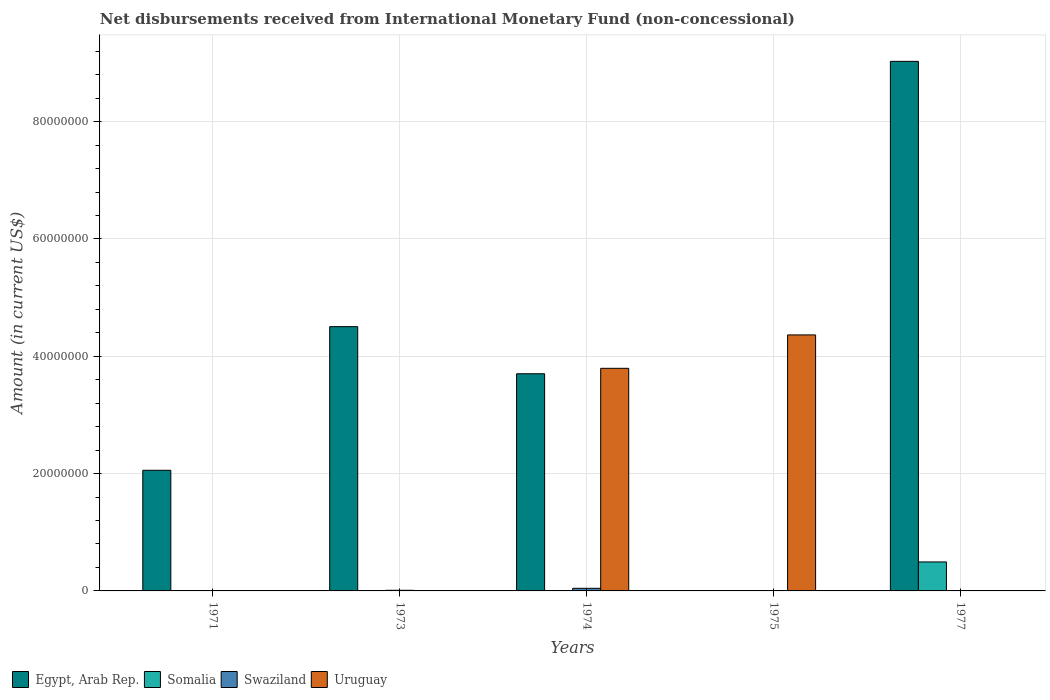How many different coloured bars are there?
Ensure brevity in your answer.  4. Are the number of bars per tick equal to the number of legend labels?
Your response must be concise. No. What is the label of the 4th group of bars from the left?
Provide a succinct answer. 1975. In how many cases, is the number of bars for a given year not equal to the number of legend labels?
Offer a very short reply. 5. What is the amount of disbursements received from International Monetary Fund in Uruguay in 1974?
Keep it short and to the point. 3.79e+07. Across all years, what is the maximum amount of disbursements received from International Monetary Fund in Egypt, Arab Rep.?
Give a very brief answer. 9.03e+07. What is the total amount of disbursements received from International Monetary Fund in Uruguay in the graph?
Provide a succinct answer. 8.16e+07. What is the difference between the amount of disbursements received from International Monetary Fund in Swaziland in 1973 and that in 1974?
Provide a succinct answer. -3.37e+05. What is the average amount of disbursements received from International Monetary Fund in Swaziland per year?
Your response must be concise. 1.11e+05. In the year 1973, what is the difference between the amount of disbursements received from International Monetary Fund in Swaziland and amount of disbursements received from International Monetary Fund in Egypt, Arab Rep.?
Your answer should be very brief. -4.49e+07. In how many years, is the amount of disbursements received from International Monetary Fund in Egypt, Arab Rep. greater than 24000000 US$?
Make the answer very short. 3. What is the difference between the highest and the second highest amount of disbursements received from International Monetary Fund in Egypt, Arab Rep.?
Give a very brief answer. 4.52e+07. What is the difference between the highest and the lowest amount of disbursements received from International Monetary Fund in Swaziland?
Your answer should be compact. 4.45e+05. Is it the case that in every year, the sum of the amount of disbursements received from International Monetary Fund in Swaziland and amount of disbursements received from International Monetary Fund in Somalia is greater than the sum of amount of disbursements received from International Monetary Fund in Uruguay and amount of disbursements received from International Monetary Fund in Egypt, Arab Rep.?
Your answer should be compact. No. Is it the case that in every year, the sum of the amount of disbursements received from International Monetary Fund in Somalia and amount of disbursements received from International Monetary Fund in Swaziland is greater than the amount of disbursements received from International Monetary Fund in Egypt, Arab Rep.?
Your answer should be compact. No. How many bars are there?
Your response must be concise. 9. What is the difference between two consecutive major ticks on the Y-axis?
Your answer should be compact. 2.00e+07. Are the values on the major ticks of Y-axis written in scientific E-notation?
Offer a terse response. No. Where does the legend appear in the graph?
Give a very brief answer. Bottom left. How many legend labels are there?
Your response must be concise. 4. How are the legend labels stacked?
Keep it short and to the point. Horizontal. What is the title of the graph?
Give a very brief answer. Net disbursements received from International Monetary Fund (non-concessional). Does "Armenia" appear as one of the legend labels in the graph?
Your response must be concise. No. What is the label or title of the X-axis?
Provide a short and direct response. Years. What is the label or title of the Y-axis?
Keep it short and to the point. Amount (in current US$). What is the Amount (in current US$) in Egypt, Arab Rep. in 1971?
Keep it short and to the point. 2.06e+07. What is the Amount (in current US$) in Uruguay in 1971?
Ensure brevity in your answer.  0. What is the Amount (in current US$) of Egypt, Arab Rep. in 1973?
Provide a short and direct response. 4.50e+07. What is the Amount (in current US$) in Somalia in 1973?
Offer a very short reply. 0. What is the Amount (in current US$) of Swaziland in 1973?
Provide a succinct answer. 1.08e+05. What is the Amount (in current US$) in Uruguay in 1973?
Make the answer very short. 0. What is the Amount (in current US$) in Egypt, Arab Rep. in 1974?
Your response must be concise. 3.70e+07. What is the Amount (in current US$) of Swaziland in 1974?
Make the answer very short. 4.45e+05. What is the Amount (in current US$) in Uruguay in 1974?
Keep it short and to the point. 3.79e+07. What is the Amount (in current US$) of Egypt, Arab Rep. in 1975?
Ensure brevity in your answer.  0. What is the Amount (in current US$) of Somalia in 1975?
Keep it short and to the point. 0. What is the Amount (in current US$) in Swaziland in 1975?
Offer a very short reply. 0. What is the Amount (in current US$) in Uruguay in 1975?
Provide a short and direct response. 4.36e+07. What is the Amount (in current US$) of Egypt, Arab Rep. in 1977?
Provide a succinct answer. 9.03e+07. What is the Amount (in current US$) of Somalia in 1977?
Make the answer very short. 4.94e+06. Across all years, what is the maximum Amount (in current US$) in Egypt, Arab Rep.?
Make the answer very short. 9.03e+07. Across all years, what is the maximum Amount (in current US$) in Somalia?
Offer a terse response. 4.94e+06. Across all years, what is the maximum Amount (in current US$) of Swaziland?
Offer a very short reply. 4.45e+05. Across all years, what is the maximum Amount (in current US$) of Uruguay?
Give a very brief answer. 4.36e+07. Across all years, what is the minimum Amount (in current US$) of Egypt, Arab Rep.?
Offer a very short reply. 0. Across all years, what is the minimum Amount (in current US$) of Uruguay?
Your answer should be compact. 0. What is the total Amount (in current US$) in Egypt, Arab Rep. in the graph?
Provide a short and direct response. 1.93e+08. What is the total Amount (in current US$) of Somalia in the graph?
Your answer should be very brief. 4.94e+06. What is the total Amount (in current US$) of Swaziland in the graph?
Provide a succinct answer. 5.53e+05. What is the total Amount (in current US$) of Uruguay in the graph?
Your response must be concise. 8.16e+07. What is the difference between the Amount (in current US$) in Egypt, Arab Rep. in 1971 and that in 1973?
Offer a very short reply. -2.45e+07. What is the difference between the Amount (in current US$) in Egypt, Arab Rep. in 1971 and that in 1974?
Your answer should be very brief. -1.65e+07. What is the difference between the Amount (in current US$) of Egypt, Arab Rep. in 1971 and that in 1977?
Your answer should be very brief. -6.97e+07. What is the difference between the Amount (in current US$) of Egypt, Arab Rep. in 1973 and that in 1974?
Provide a succinct answer. 8.03e+06. What is the difference between the Amount (in current US$) of Swaziland in 1973 and that in 1974?
Your answer should be compact. -3.37e+05. What is the difference between the Amount (in current US$) of Egypt, Arab Rep. in 1973 and that in 1977?
Provide a short and direct response. -4.52e+07. What is the difference between the Amount (in current US$) in Uruguay in 1974 and that in 1975?
Your answer should be compact. -5.69e+06. What is the difference between the Amount (in current US$) in Egypt, Arab Rep. in 1974 and that in 1977?
Keep it short and to the point. -5.33e+07. What is the difference between the Amount (in current US$) in Egypt, Arab Rep. in 1971 and the Amount (in current US$) in Swaziland in 1973?
Make the answer very short. 2.05e+07. What is the difference between the Amount (in current US$) of Egypt, Arab Rep. in 1971 and the Amount (in current US$) of Swaziland in 1974?
Your answer should be compact. 2.01e+07. What is the difference between the Amount (in current US$) in Egypt, Arab Rep. in 1971 and the Amount (in current US$) in Uruguay in 1974?
Give a very brief answer. -1.74e+07. What is the difference between the Amount (in current US$) of Egypt, Arab Rep. in 1971 and the Amount (in current US$) of Uruguay in 1975?
Provide a short and direct response. -2.31e+07. What is the difference between the Amount (in current US$) in Egypt, Arab Rep. in 1971 and the Amount (in current US$) in Somalia in 1977?
Keep it short and to the point. 1.56e+07. What is the difference between the Amount (in current US$) in Egypt, Arab Rep. in 1973 and the Amount (in current US$) in Swaziland in 1974?
Give a very brief answer. 4.46e+07. What is the difference between the Amount (in current US$) in Egypt, Arab Rep. in 1973 and the Amount (in current US$) in Uruguay in 1974?
Keep it short and to the point. 7.10e+06. What is the difference between the Amount (in current US$) in Swaziland in 1973 and the Amount (in current US$) in Uruguay in 1974?
Your answer should be compact. -3.78e+07. What is the difference between the Amount (in current US$) in Egypt, Arab Rep. in 1973 and the Amount (in current US$) in Uruguay in 1975?
Provide a short and direct response. 1.41e+06. What is the difference between the Amount (in current US$) in Swaziland in 1973 and the Amount (in current US$) in Uruguay in 1975?
Your response must be concise. -4.35e+07. What is the difference between the Amount (in current US$) in Egypt, Arab Rep. in 1973 and the Amount (in current US$) in Somalia in 1977?
Your response must be concise. 4.01e+07. What is the difference between the Amount (in current US$) in Egypt, Arab Rep. in 1974 and the Amount (in current US$) in Uruguay in 1975?
Your answer should be compact. -6.62e+06. What is the difference between the Amount (in current US$) in Swaziland in 1974 and the Amount (in current US$) in Uruguay in 1975?
Keep it short and to the point. -4.32e+07. What is the difference between the Amount (in current US$) of Egypt, Arab Rep. in 1974 and the Amount (in current US$) of Somalia in 1977?
Your response must be concise. 3.21e+07. What is the average Amount (in current US$) in Egypt, Arab Rep. per year?
Offer a terse response. 3.86e+07. What is the average Amount (in current US$) in Somalia per year?
Provide a succinct answer. 9.88e+05. What is the average Amount (in current US$) in Swaziland per year?
Your answer should be compact. 1.11e+05. What is the average Amount (in current US$) in Uruguay per year?
Provide a succinct answer. 1.63e+07. In the year 1973, what is the difference between the Amount (in current US$) of Egypt, Arab Rep. and Amount (in current US$) of Swaziland?
Keep it short and to the point. 4.49e+07. In the year 1974, what is the difference between the Amount (in current US$) of Egypt, Arab Rep. and Amount (in current US$) of Swaziland?
Keep it short and to the point. 3.66e+07. In the year 1974, what is the difference between the Amount (in current US$) in Egypt, Arab Rep. and Amount (in current US$) in Uruguay?
Offer a very short reply. -9.26e+05. In the year 1974, what is the difference between the Amount (in current US$) of Swaziland and Amount (in current US$) of Uruguay?
Your answer should be very brief. -3.75e+07. In the year 1977, what is the difference between the Amount (in current US$) in Egypt, Arab Rep. and Amount (in current US$) in Somalia?
Your response must be concise. 8.53e+07. What is the ratio of the Amount (in current US$) in Egypt, Arab Rep. in 1971 to that in 1973?
Make the answer very short. 0.46. What is the ratio of the Amount (in current US$) of Egypt, Arab Rep. in 1971 to that in 1974?
Keep it short and to the point. 0.56. What is the ratio of the Amount (in current US$) in Egypt, Arab Rep. in 1971 to that in 1977?
Keep it short and to the point. 0.23. What is the ratio of the Amount (in current US$) of Egypt, Arab Rep. in 1973 to that in 1974?
Provide a short and direct response. 1.22. What is the ratio of the Amount (in current US$) of Swaziland in 1973 to that in 1974?
Keep it short and to the point. 0.24. What is the ratio of the Amount (in current US$) of Egypt, Arab Rep. in 1973 to that in 1977?
Your answer should be compact. 0.5. What is the ratio of the Amount (in current US$) of Uruguay in 1974 to that in 1975?
Offer a terse response. 0.87. What is the ratio of the Amount (in current US$) of Egypt, Arab Rep. in 1974 to that in 1977?
Your response must be concise. 0.41. What is the difference between the highest and the second highest Amount (in current US$) of Egypt, Arab Rep.?
Make the answer very short. 4.52e+07. What is the difference between the highest and the lowest Amount (in current US$) of Egypt, Arab Rep.?
Provide a short and direct response. 9.03e+07. What is the difference between the highest and the lowest Amount (in current US$) of Somalia?
Offer a very short reply. 4.94e+06. What is the difference between the highest and the lowest Amount (in current US$) in Swaziland?
Ensure brevity in your answer.  4.45e+05. What is the difference between the highest and the lowest Amount (in current US$) in Uruguay?
Offer a terse response. 4.36e+07. 